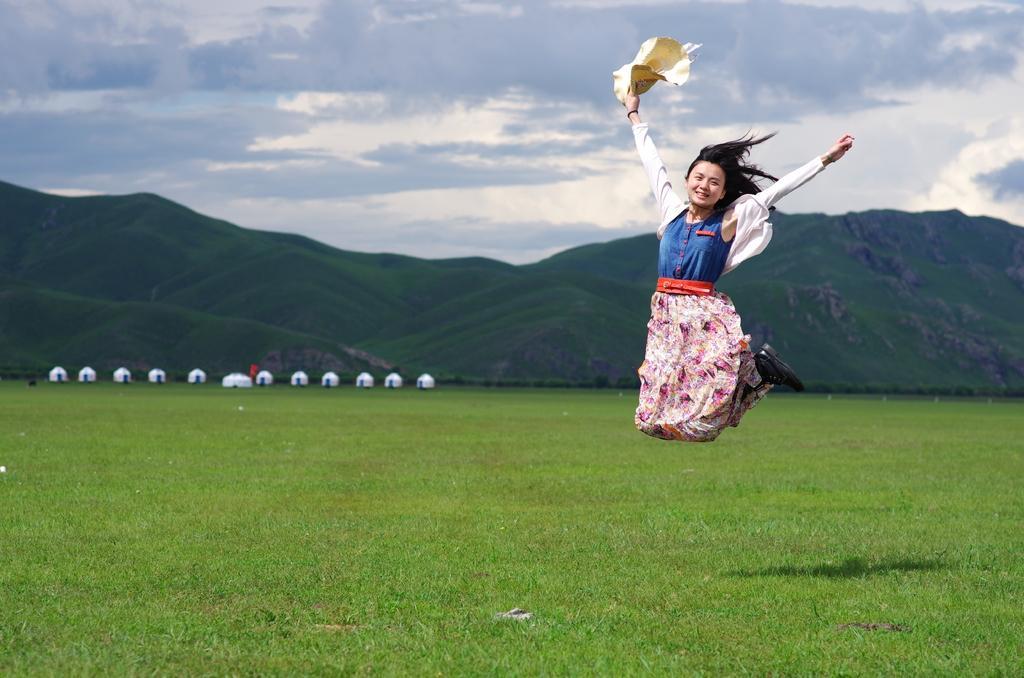Please provide a concise description of this image. In this picture I can see a woman jumping and holding a cap in her hand and I can see hills and a blue cloudy sky and looks like few tents on the back and I can see grass on the ground. 